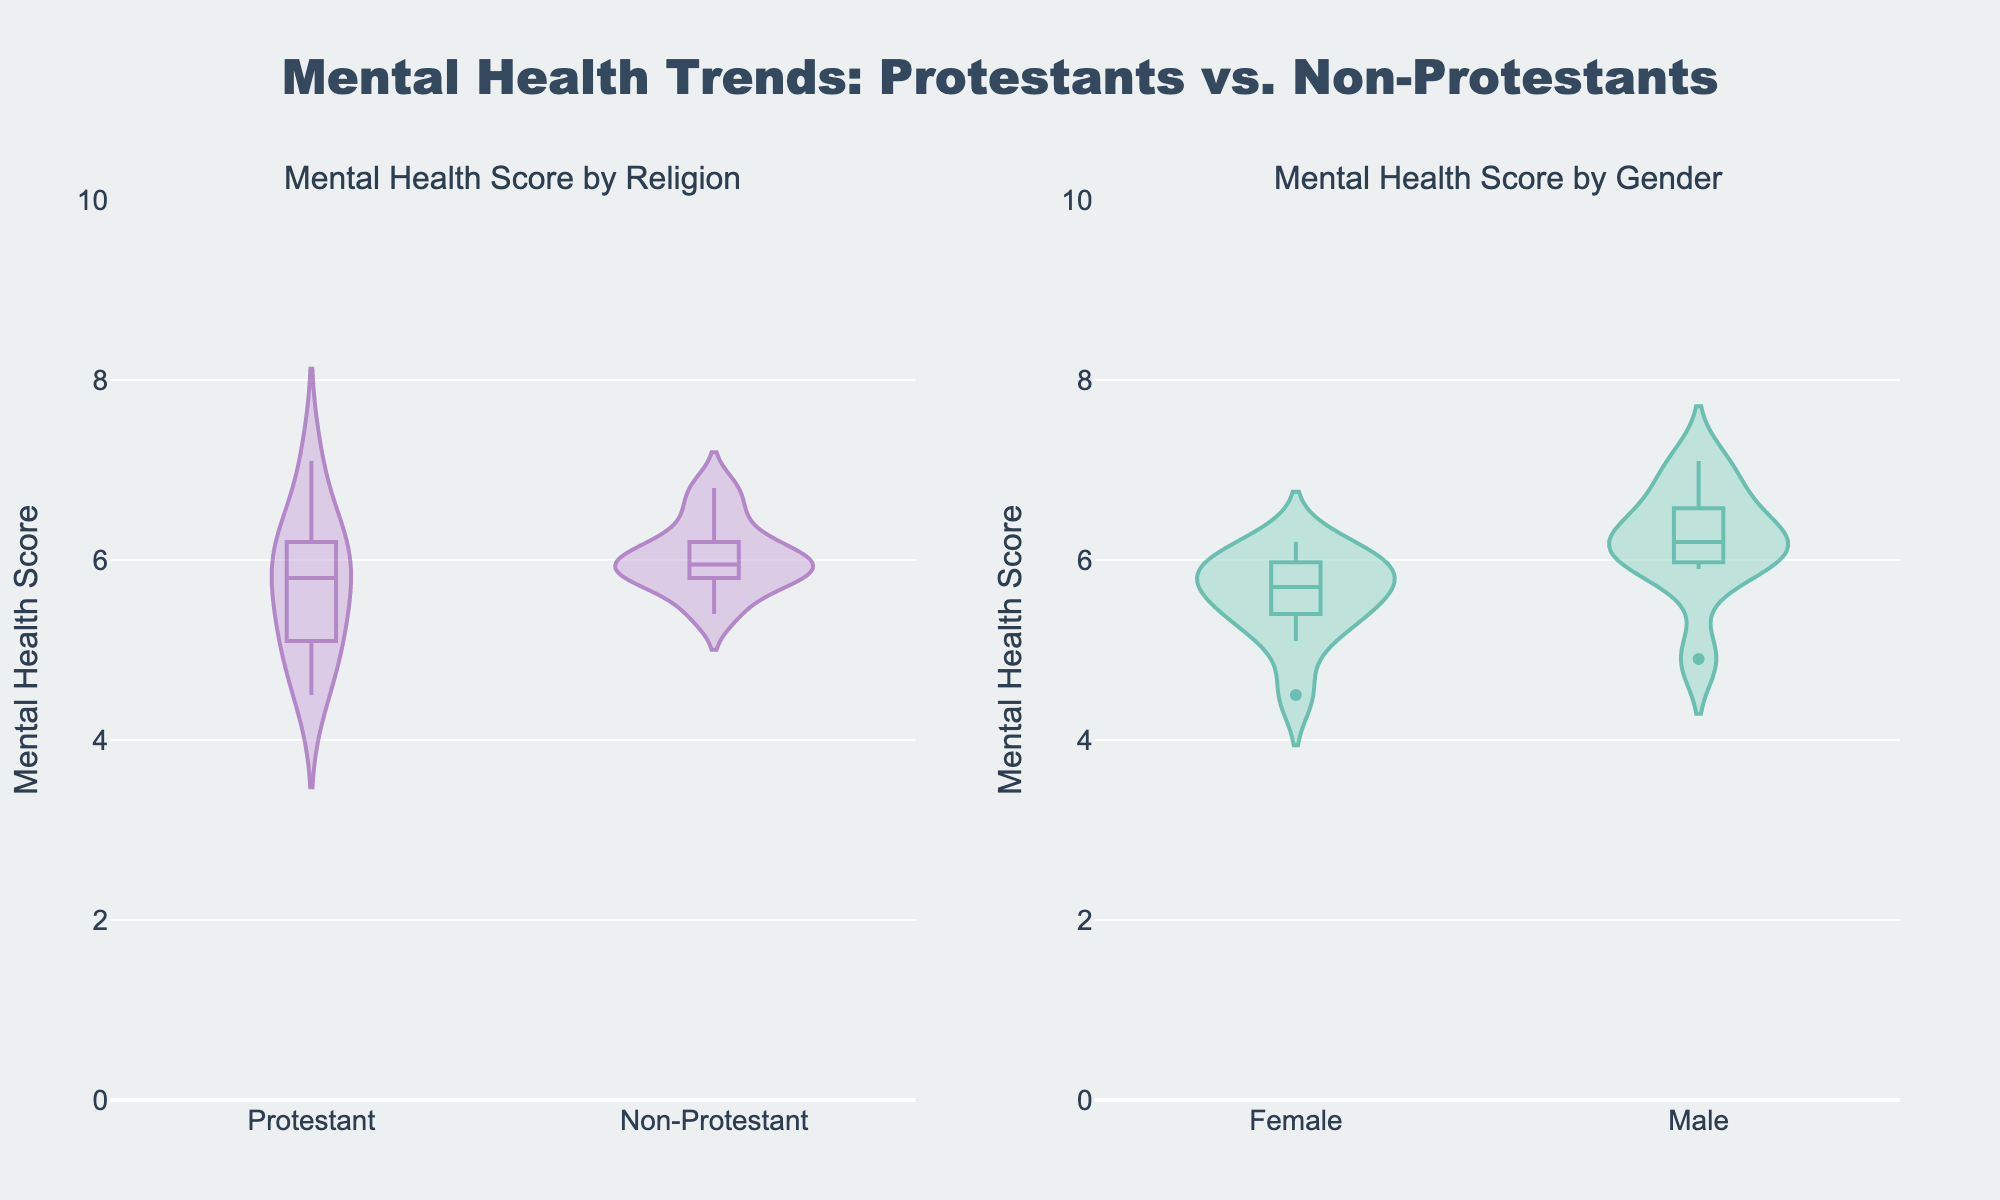What is the title of the subplot on the left? The title of the subplot on the left is displayed above the subplot. The subplot on the left is titled "Mental Health Score by Religion".
Answer: Mental Health Score by Religion Which group appears to have a wider spread in mental health scores, Protestants or Non-Protestants? To determine which group has a wider spread, you look at the range of the violin plot on the y-axis. The Protestant group appears to have a wider spread in mental health scores, ranging from approximately 4.5 to 7.1, while Non-Protestants range from approximately 5.4 to 6.8.
Answer: Protestants What is the median mental health score for Protestants, approximately? The median is indicated by the line inside the box of the violin plot. For Protestants, the median appears to be around 6.0.
Answer: 6.0 Which gender has a higher median mental health score? By examining the box plot within the violin plots for each gender, the median mental health score for females appears to be slightly lower than for males. Therefore, males have a higher median score.
Answer: Male What is the range of mental health scores for Non-Protestant females? The range of the violin plot for Non-Protestant females on the y-axis shows the lowest and highest values. For Non-Protestant females, scores range approximately from 5.4 to 6.5.
Answer: 5.4 to 6.5 Compare the median mental health scores of Protestant males and females. The line within the box of the violin plots indicates the median. The median for Protestant males appears slightly higher than for Protestant females.
Answer: Protestant males have a higher median Which subplot shows greater variability in mental health scores, by Religion or by Gender? Variability can be assessed by looking at the spread of the violin plots. The plot by Religion shows greater variability as the spread of the violin plots for Protestants and Non-Protestants is wider compared to the plot by Gender.
Answer: By Religion Are there any visible outliers in the violin plot for males? Outliers are typically shown as points outside the main distribution. The violin plot for males does not show any apparent outliers, as all data points seem to fall within a consistent range.
Answer: No What is the maximum mental health score observed among Protestants? The highest point in the violin plot for Protestants indicates the maximum score. The maximum mental health score for Protestants is approximately 7.1.
Answer: 7.1 